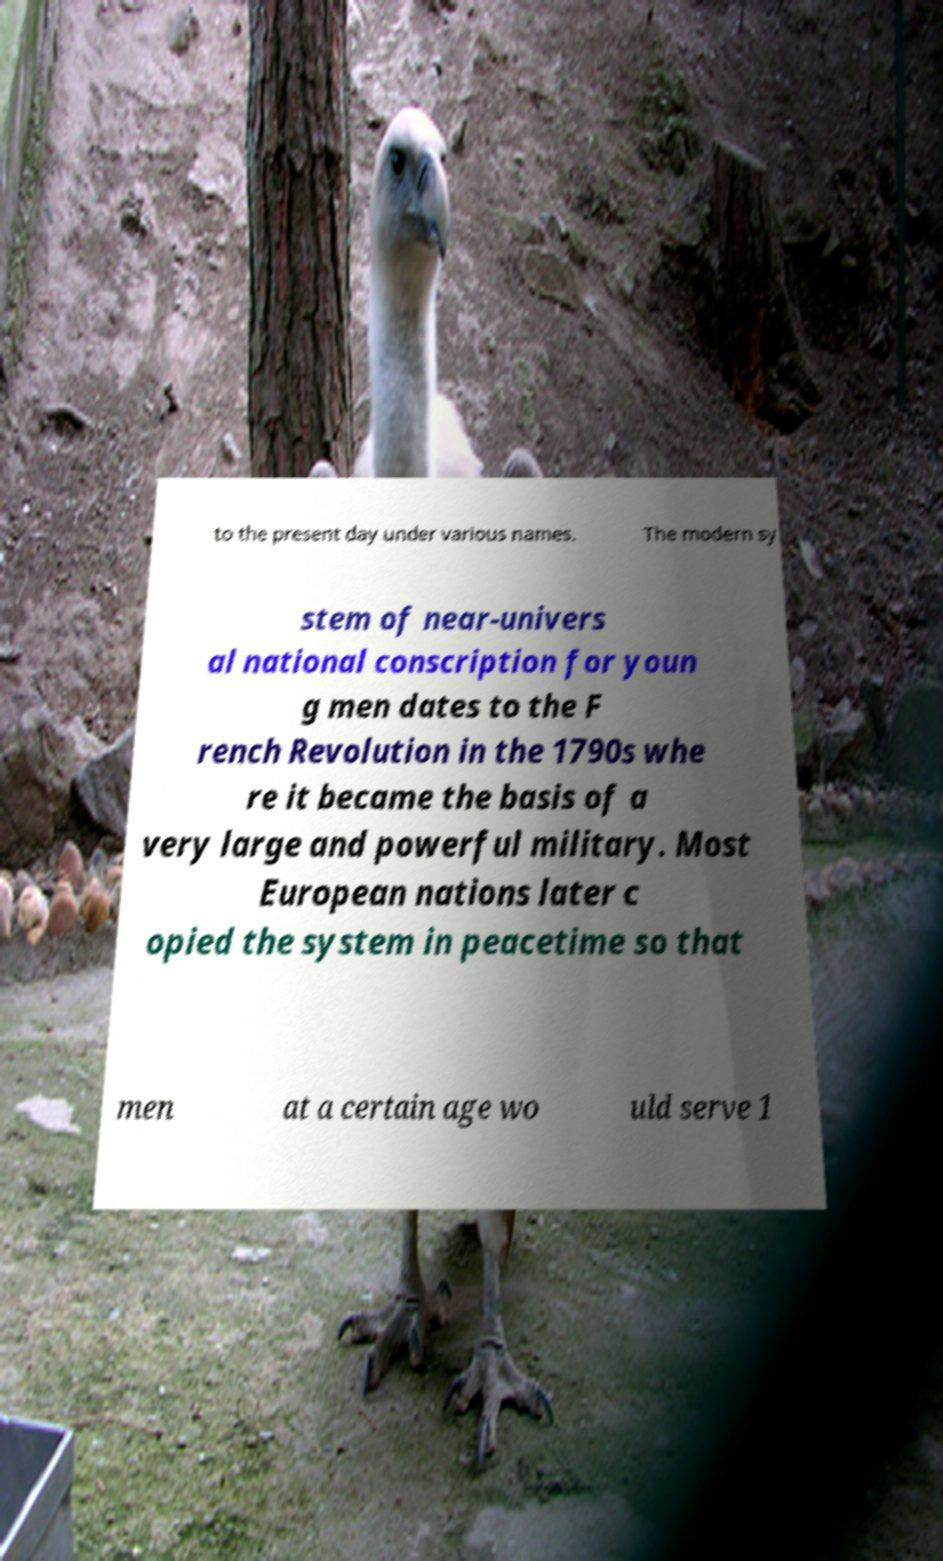Could you assist in decoding the text presented in this image and type it out clearly? to the present day under various names. The modern sy stem of near-univers al national conscription for youn g men dates to the F rench Revolution in the 1790s whe re it became the basis of a very large and powerful military. Most European nations later c opied the system in peacetime so that men at a certain age wo uld serve 1 